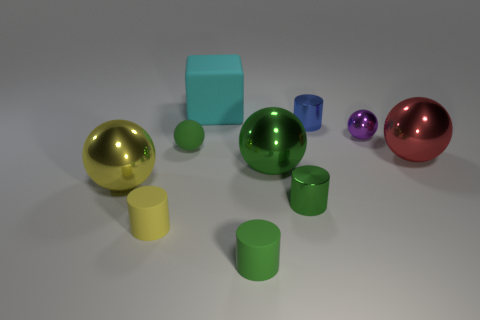Do the green rubber thing that is behind the small yellow object and the big red metal object have the same shape?
Your answer should be very brief. Yes. What color is the large cube?
Offer a very short reply. Cyan. What shape is the big metal thing that is the same color as the tiny rubber sphere?
Keep it short and to the point. Sphere. Are there any tiny shiny things?
Provide a succinct answer. Yes. The blue thing that is the same material as the purple object is what size?
Provide a short and direct response. Small. There is a tiny green matte object that is in front of the big ball that is on the right side of the tiny purple metal sphere that is right of the cyan object; what is its shape?
Your answer should be compact. Cylinder. Are there an equal number of tiny rubber cylinders that are behind the tiny purple thing and small blue shiny cylinders?
Your answer should be compact. No. What is the size of the rubber cylinder that is the same color as the tiny matte sphere?
Give a very brief answer. Small. Is the big cyan object the same shape as the purple object?
Provide a succinct answer. No. What number of objects are either spheres that are on the left side of the blue cylinder or big yellow spheres?
Keep it short and to the point. 3. 